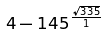<formula> <loc_0><loc_0><loc_500><loc_500>4 - 1 4 5 ^ { \frac { \sqrt { 3 3 5 } } { 1 } }</formula> 